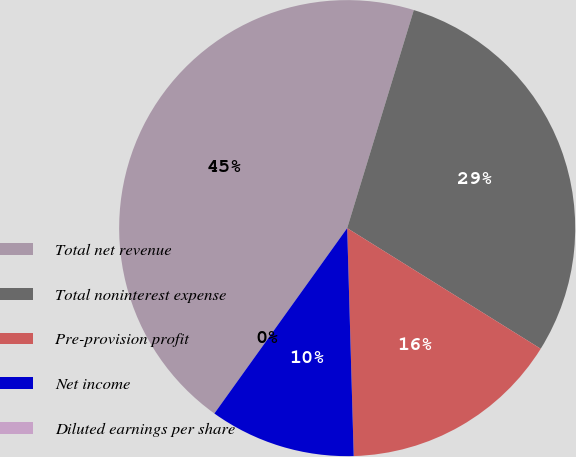Convert chart. <chart><loc_0><loc_0><loc_500><loc_500><pie_chart><fcel>Total net revenue<fcel>Total noninterest expense<fcel>Pre-provision profit<fcel>Net income<fcel>Diluted earnings per share<nl><fcel>44.82%<fcel>29.15%<fcel>15.67%<fcel>10.35%<fcel>0.0%<nl></chart> 